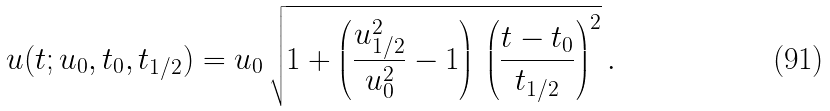Convert formula to latex. <formula><loc_0><loc_0><loc_500><loc_500>u ( t ; u _ { 0 } , t _ { 0 } , t _ { 1 / 2 } ) = u _ { 0 } \, \sqrt { 1 + \left ( \frac { u _ { 1 / 2 } ^ { 2 } } { u _ { 0 } ^ { 2 } } - 1 \right ) \, \left ( \frac { t - t _ { 0 } } { t _ { 1 / 2 } } \right ) ^ { 2 } } \, .</formula> 